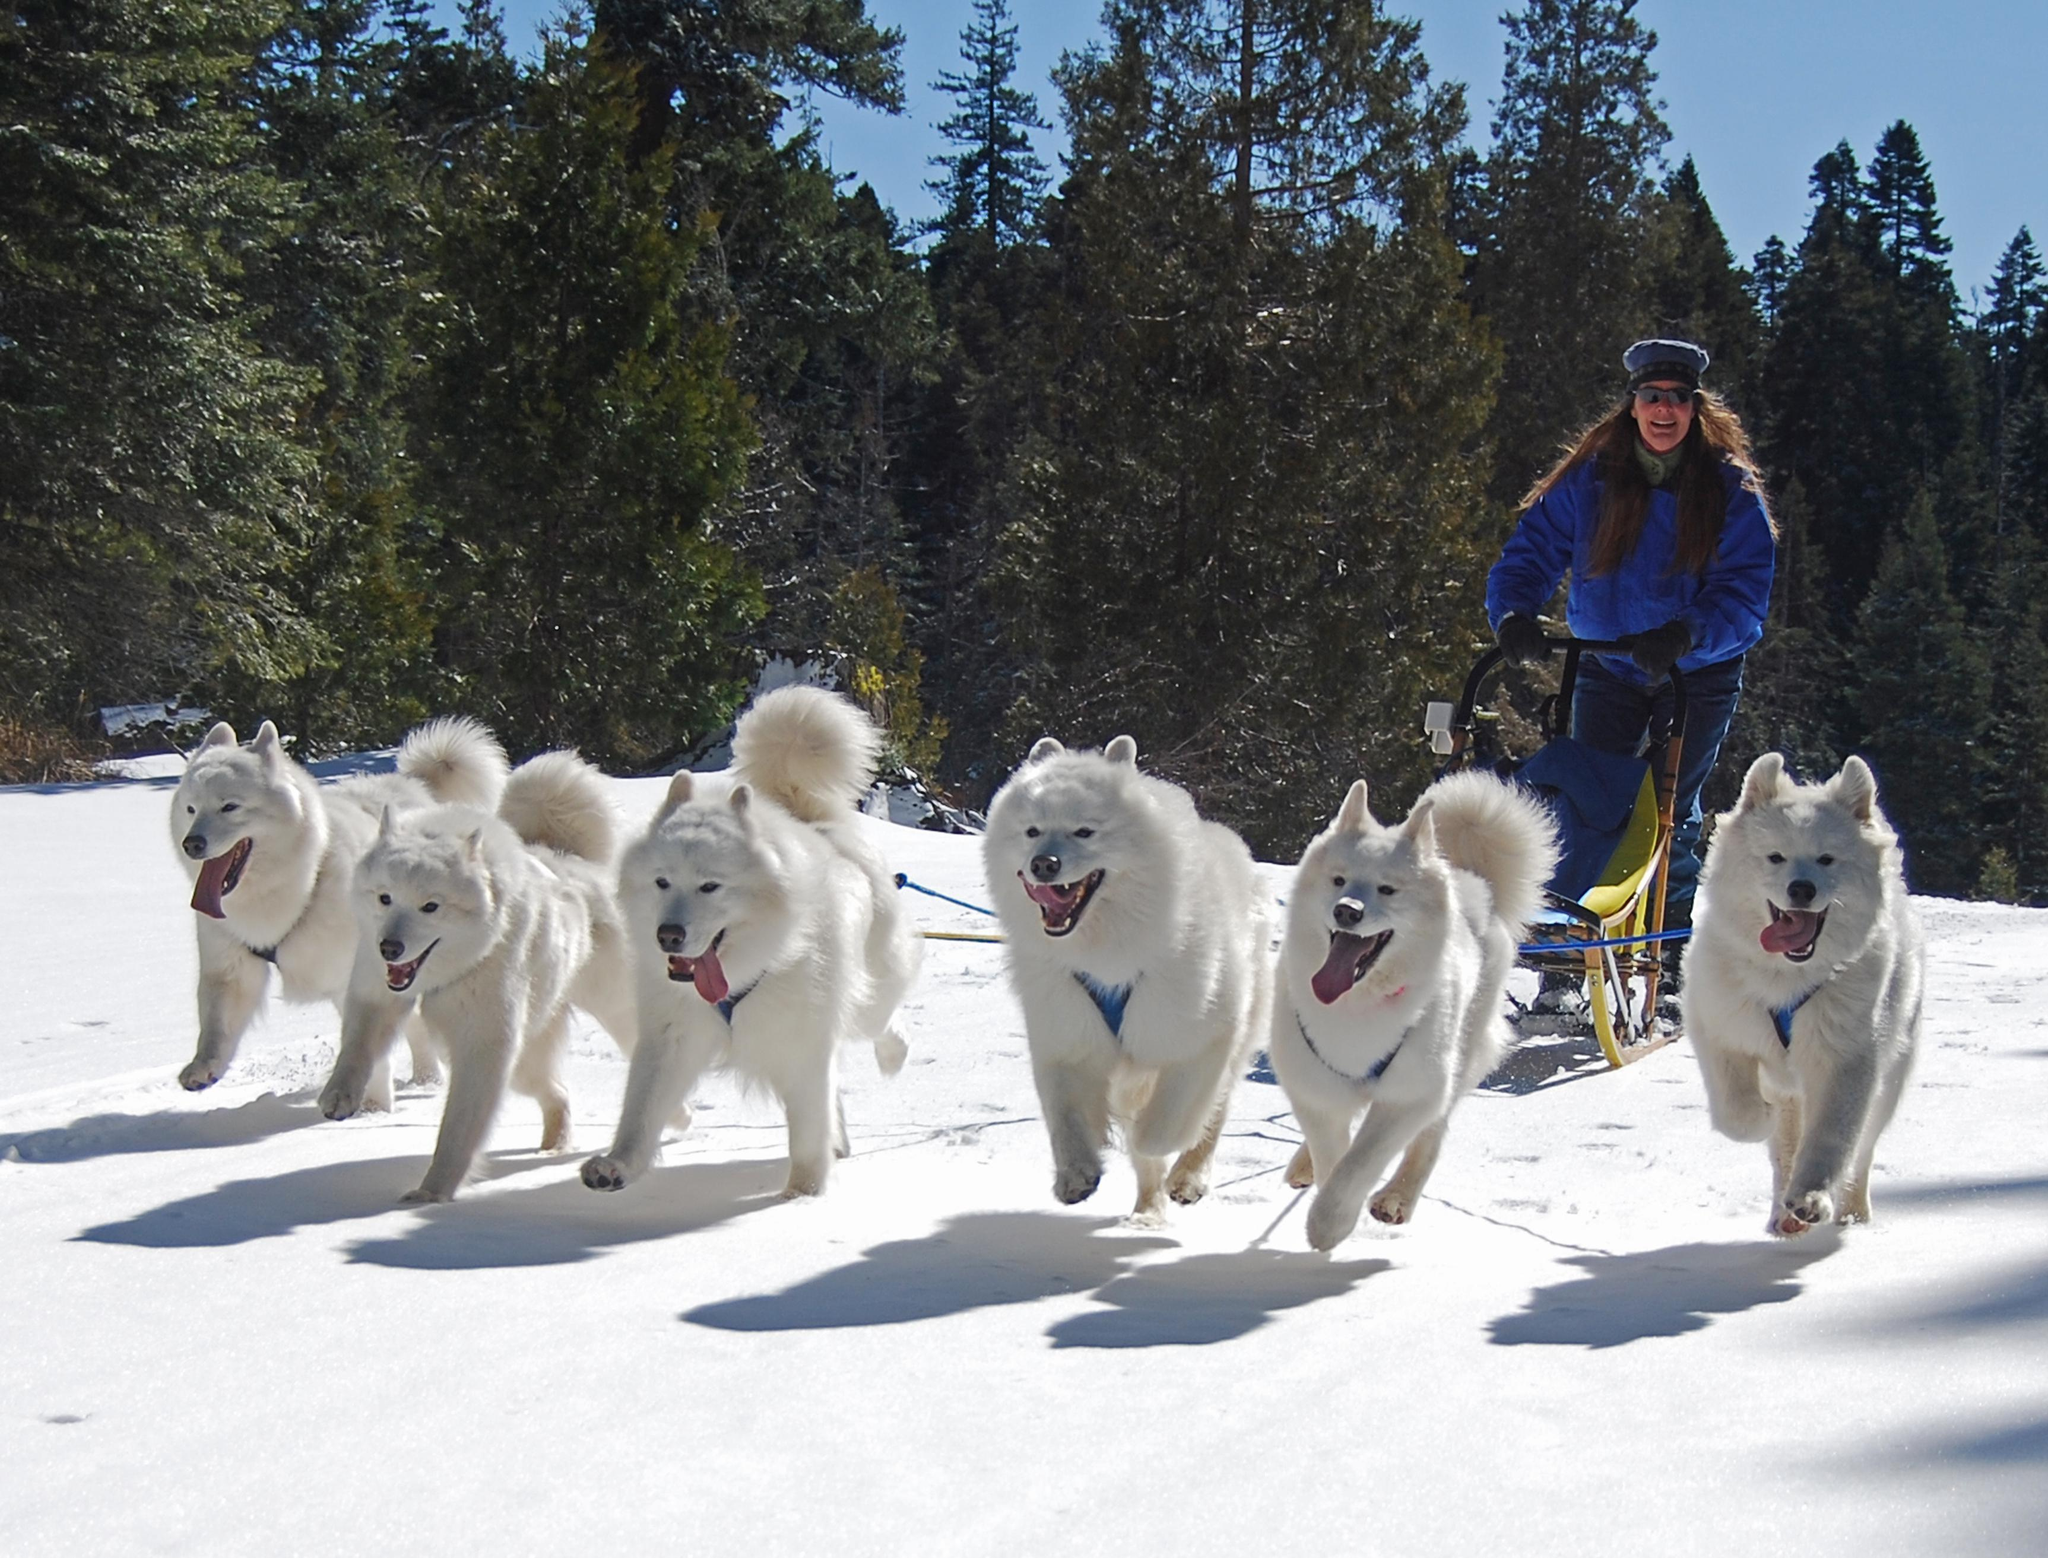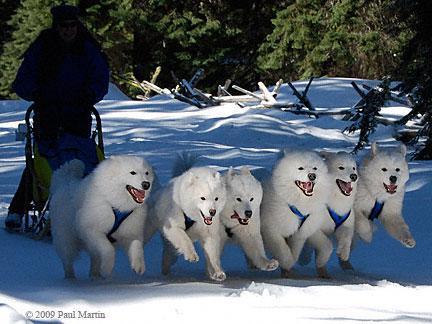The first image is the image on the left, the second image is the image on the right. Assess this claim about the two images: "There is a man wearing red outerwear on a sled.". Correct or not? Answer yes or no. No. 